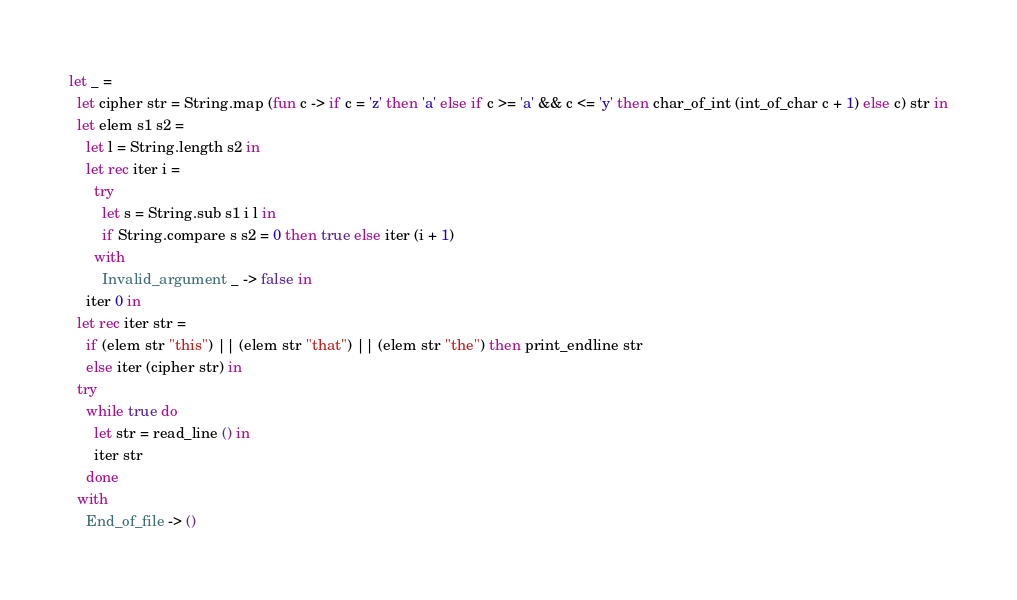Convert code to text. <code><loc_0><loc_0><loc_500><loc_500><_OCaml_>let _ =
  let cipher str = String.map (fun c -> if c = 'z' then 'a' else if c >= 'a' && c <= 'y' then char_of_int (int_of_char c + 1) else c) str in
  let elem s1 s2 =
    let l = String.length s2 in
    let rec iter i = 
      try
        let s = String.sub s1 i l in
        if String.compare s s2 = 0 then true else iter (i + 1)
      with
        Invalid_argument _ -> false in
    iter 0 in
  let rec iter str =
    if (elem str "this") || (elem str "that") || (elem str "the") then print_endline str
    else iter (cipher str) in
  try
    while true do
      let str = read_line () in
      iter str
    done
  with
    End_of_file -> ()</code> 